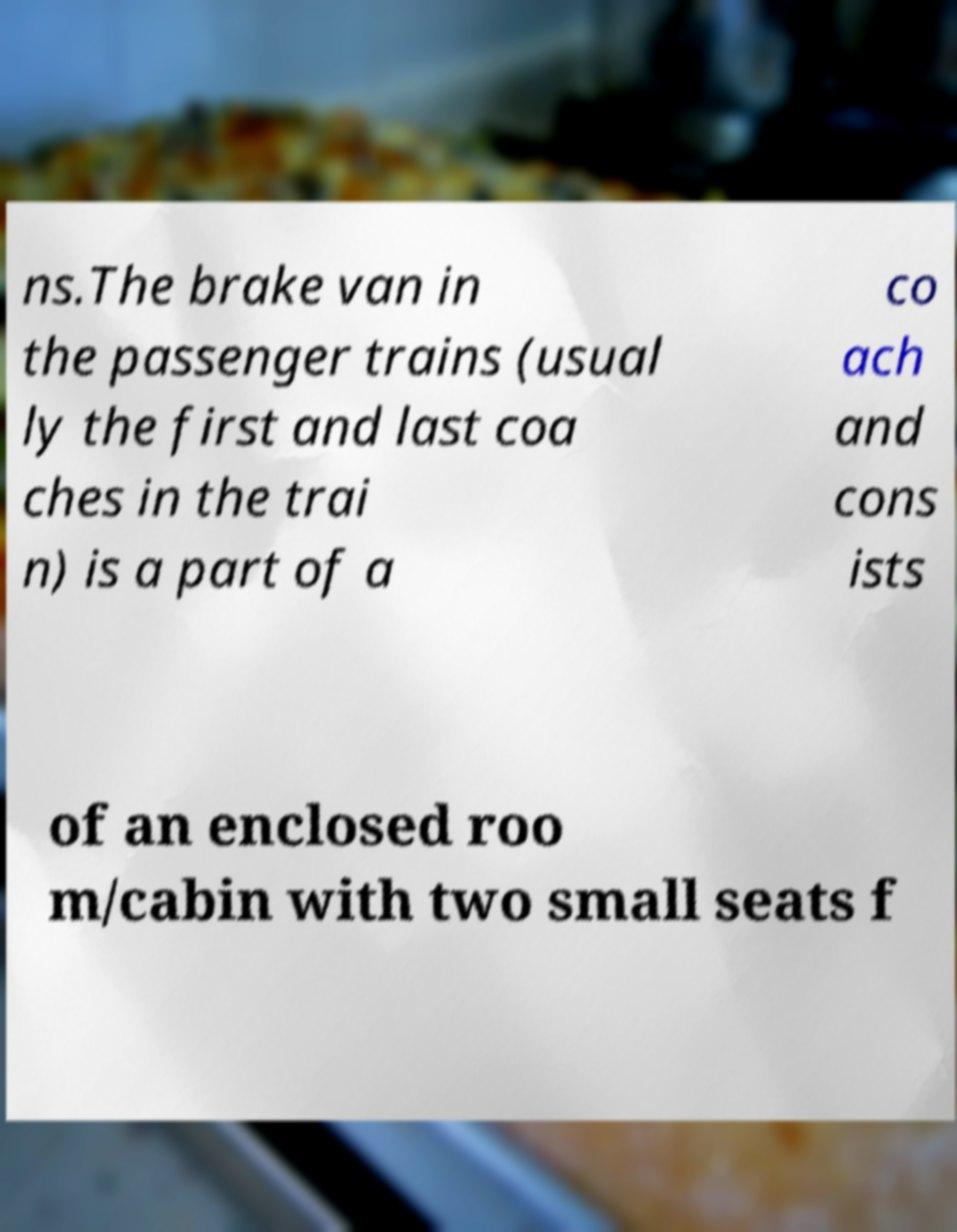Can you accurately transcribe the text from the provided image for me? ns.The brake van in the passenger trains (usual ly the first and last coa ches in the trai n) is a part of a co ach and cons ists of an enclosed roo m/cabin with two small seats f 